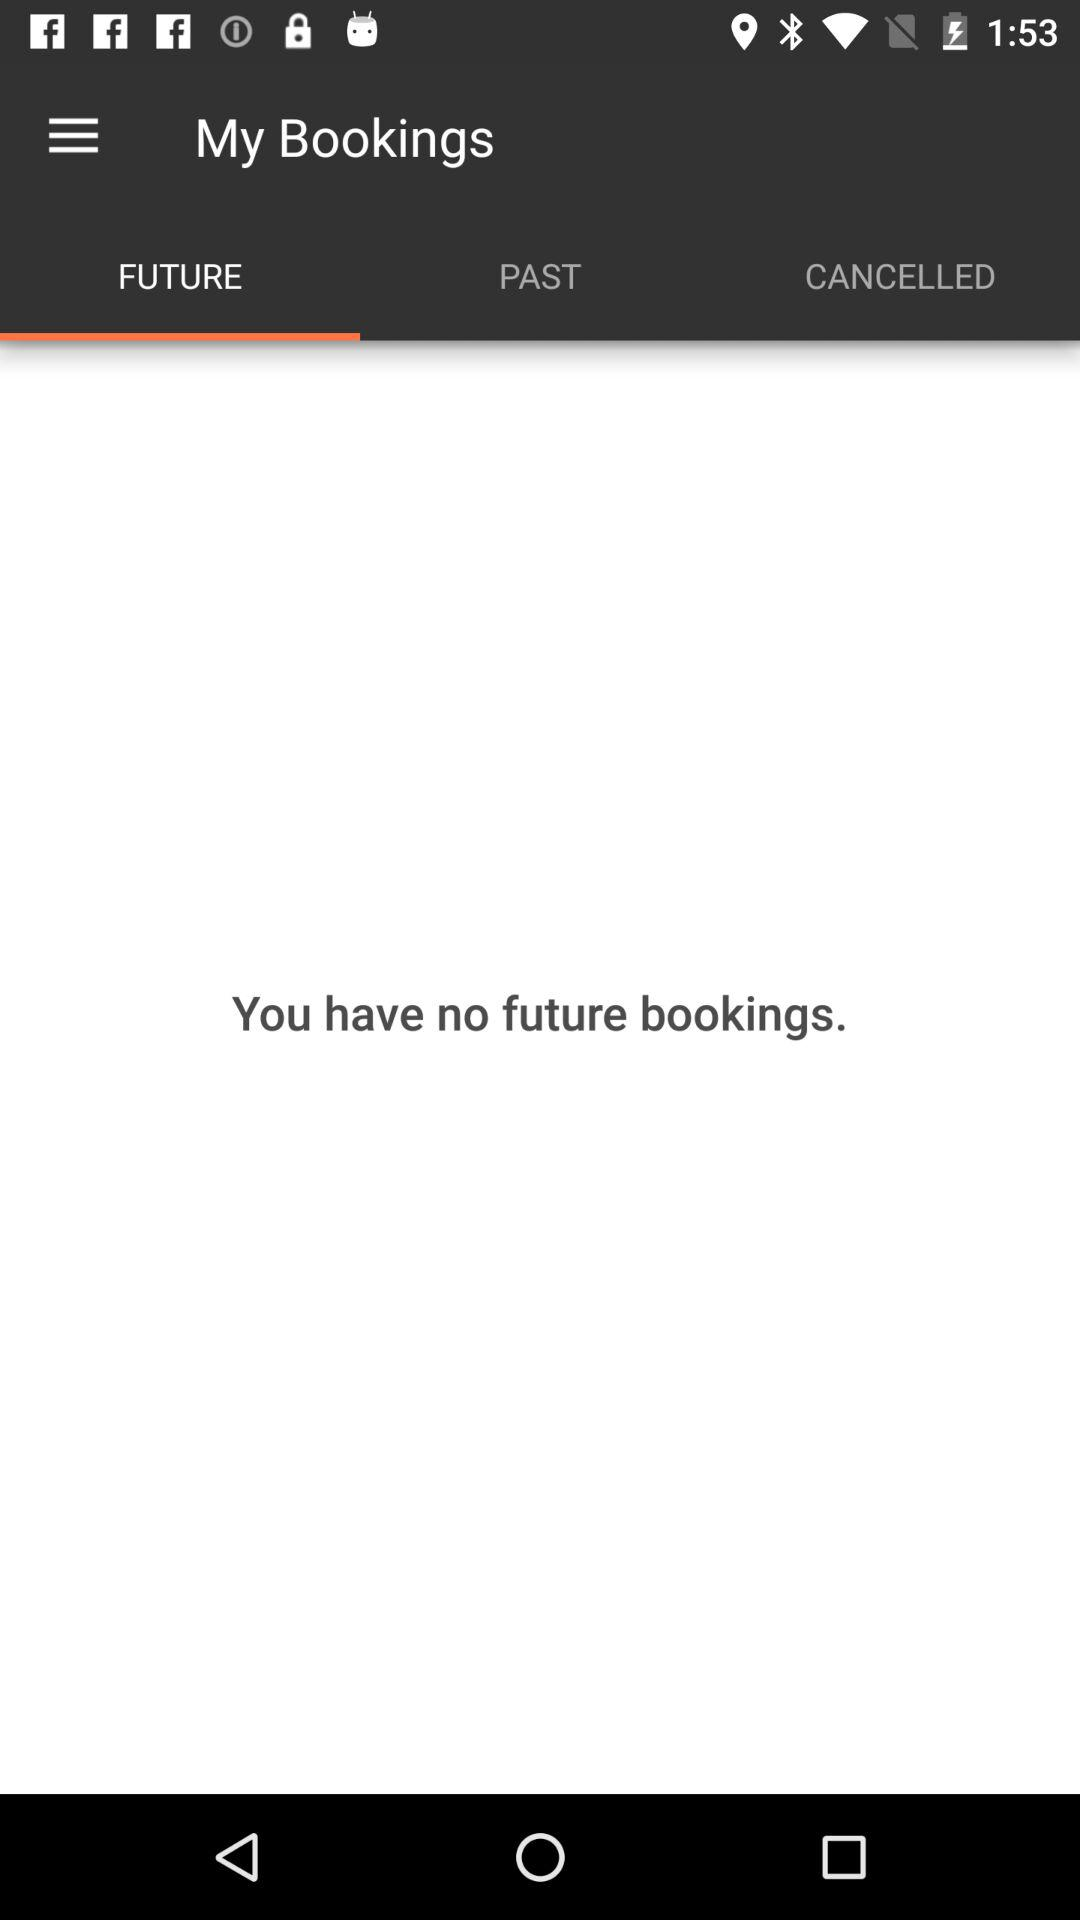How many bookings do I have?
Answer the question using a single word or phrase. 0 